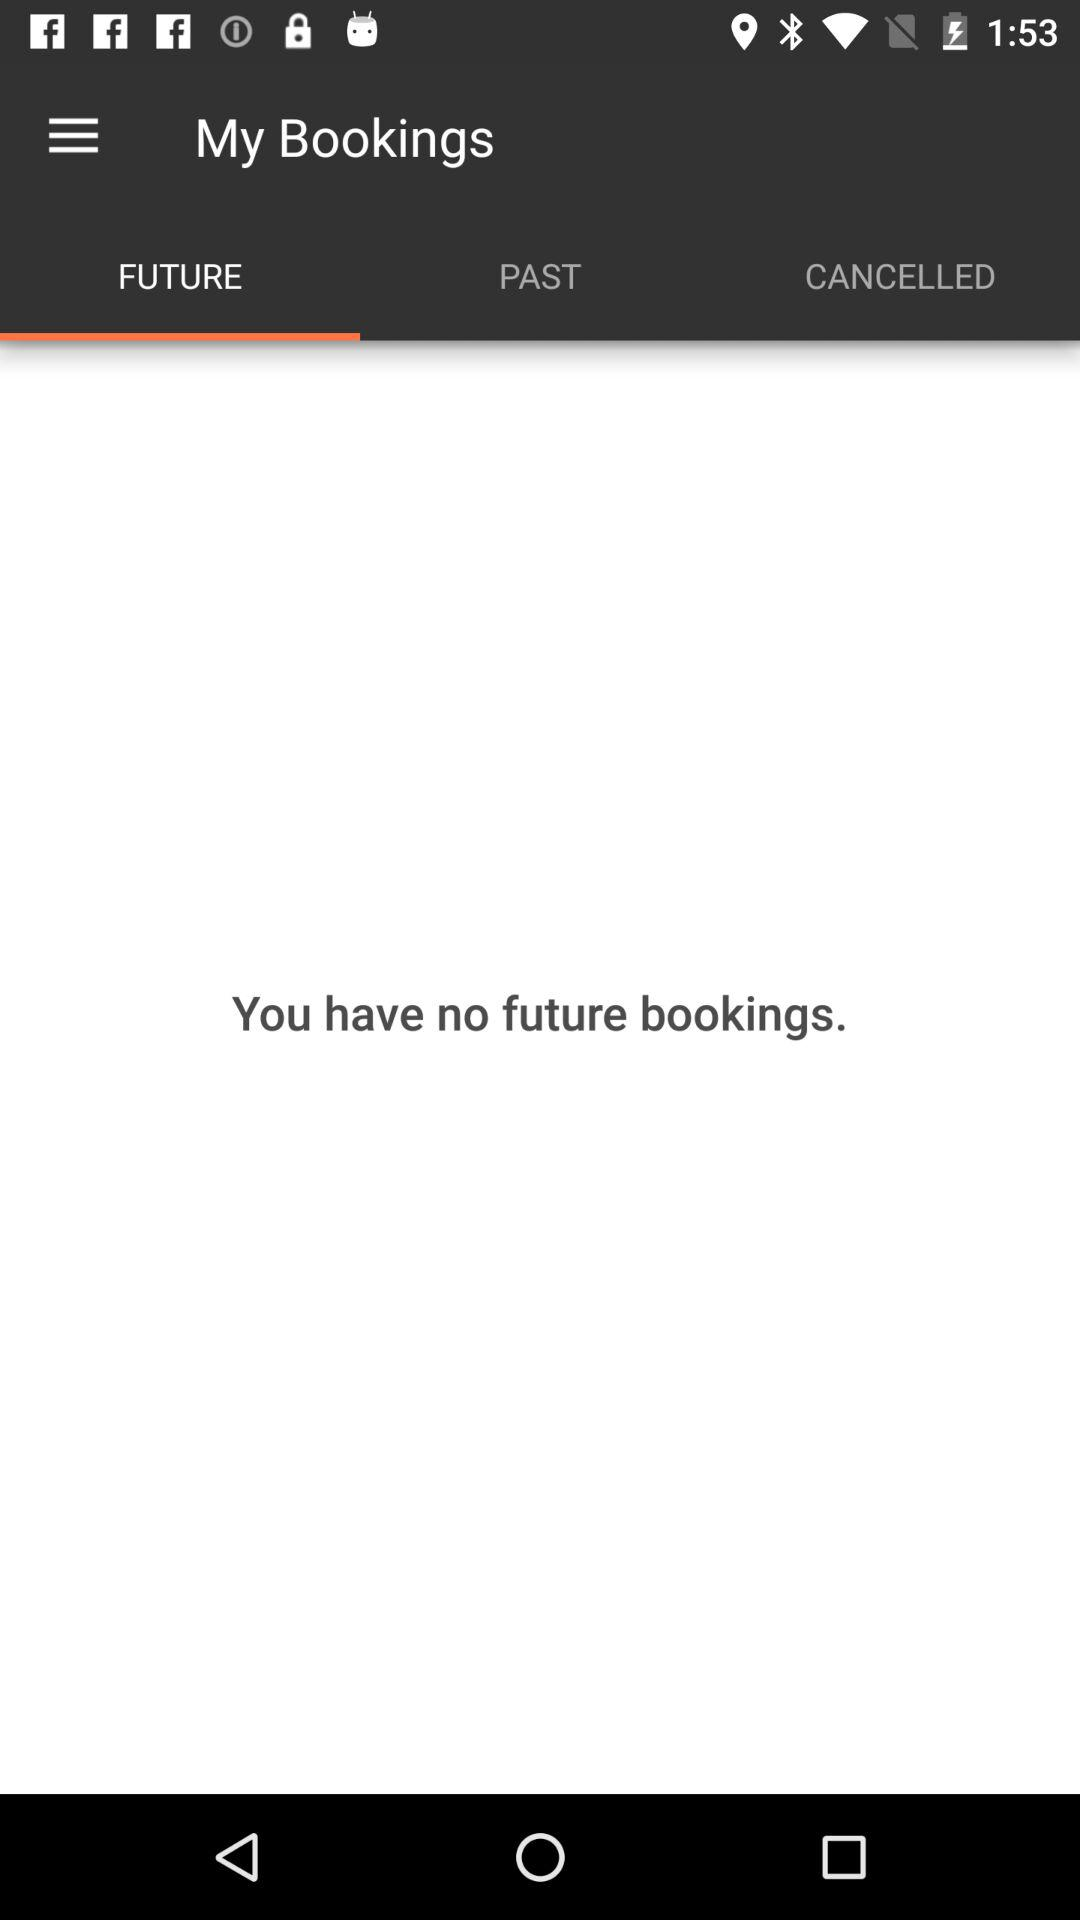How many bookings do I have?
Answer the question using a single word or phrase. 0 